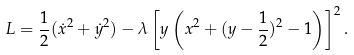Convert formula to latex. <formula><loc_0><loc_0><loc_500><loc_500>L = { \frac { 1 } { 2 } } ( \dot { x } ^ { 2 } + \dot { y } ^ { 2 } ) - \lambda \left [ y \left ( x ^ { 2 } + ( y - { \frac { 1 } { 2 } } ) ^ { 2 } - 1 \right ) \right ] ^ { 2 } .</formula> 